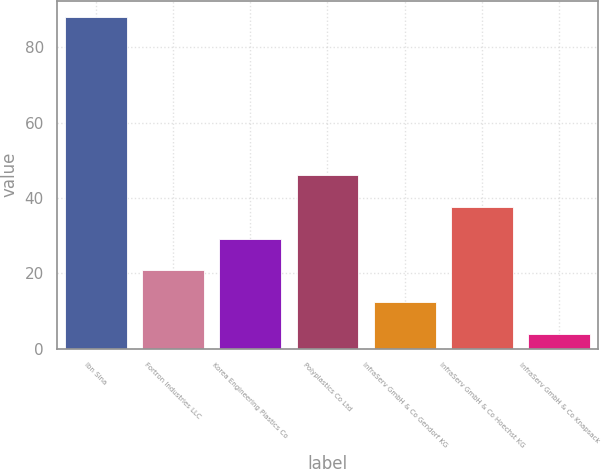Convert chart. <chart><loc_0><loc_0><loc_500><loc_500><bar_chart><fcel>Ibn Sina<fcel>Fortron Industries LLC<fcel>Korea Engineering Plastics Co<fcel>Polyplastics Co Ltd<fcel>InfraServ GmbH & Co Gendorf KG<fcel>InfraServ GmbH & Co Hoechst KG<fcel>InfraServ GmbH & Co Knapsack<nl><fcel>88<fcel>20.8<fcel>29.2<fcel>46<fcel>12.4<fcel>37.6<fcel>4<nl></chart> 